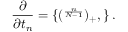Convert formula to latex. <formula><loc_0><loc_0><loc_500><loc_500>\frac { \partial \L } { \partial t _ { n } } = \{ ( \L ^ { \frac { n } { N - 1 } } ) _ { + } , \L \} \, .</formula> 